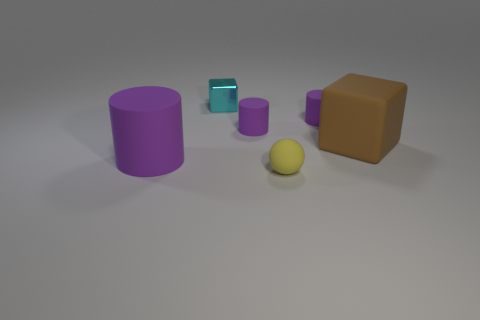What shape is the rubber object that is both in front of the large brown block and on the right side of the large matte cylinder?
Provide a succinct answer. Sphere. Is there anything else that has the same material as the big brown block?
Ensure brevity in your answer.  Yes. What is the material of the object that is in front of the big rubber block and on the right side of the cyan object?
Provide a short and direct response. Rubber. What shape is the brown thing that is made of the same material as the small yellow ball?
Offer a terse response. Cube. Is there any other thing of the same color as the metal object?
Your answer should be very brief. No. Are there more brown objects that are in front of the yellow ball than small yellow rubber objects?
Your answer should be very brief. No. What is the material of the large purple thing?
Provide a succinct answer. Rubber. What number of blue rubber objects have the same size as the cyan metal cube?
Your answer should be compact. 0. Are there the same number of purple cylinders in front of the small yellow matte ball and tiny rubber cylinders that are in front of the brown rubber thing?
Your answer should be very brief. Yes. Is the ball made of the same material as the cyan cube?
Ensure brevity in your answer.  No. 